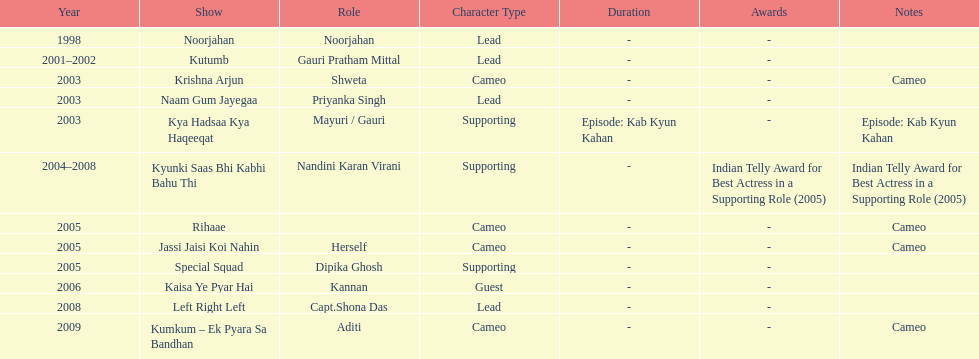How many different tv shows was gauri tejwani in before 2000? 1. 